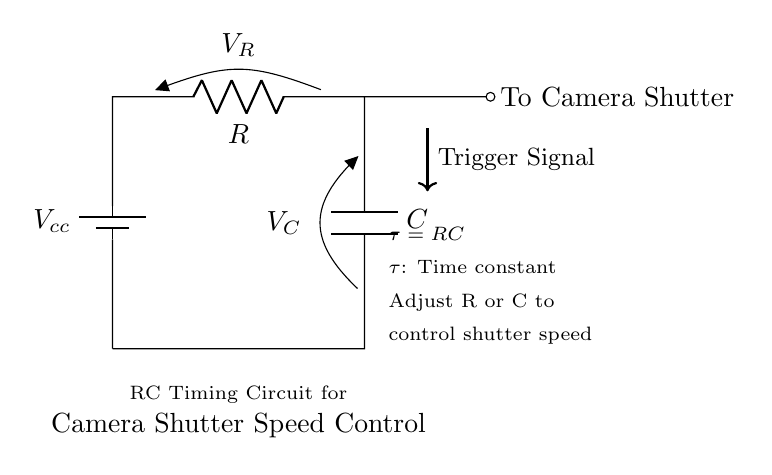What is the type of this circuit? This circuit is an RC timing circuit, which consists of a resistor and a capacitor arranged to create a time delay, particularly useful for controlling shutter speed in camera applications.
Answer: RC timing circuit What is the component labeled R? The component labeled R in the circuit is a resistor, which is used to limit the current and influence the charging time of the capacitor, thus affecting the time constant of the circuit.
Answer: Resistor What does the capacitor C do in this circuit? The capacitor C stores electrical energy and influences the time it takes for the voltage across it to rise or fall, thus controlling how long the camera shutter remains open when triggered.
Answer: Stores energy What is the formula for the time constant in this circuit? The formula for the time constant is τ = RC, where R is the resistance value and C is the capacitance value; this time constant determines how quickly the capacitor charges and discharges, affecting the shutter speed.
Answer: τ = RC How can adjusting R or C influence shutter speed? Adjusting the values of the resistor or capacitor changes the time constant τ, which directly impacts the duration for which the camera shutter remains open by altering the charging and discharging times of the capacitor.
Answer: Control shutter speed What initiates the shutter trigger signal? The trigger signal, shown by the arrow and label, is likely initiated by another electronic component or system that sends a voltage pulse to activate the camera shutter, providing control over exposure timing.
Answer: Another component 